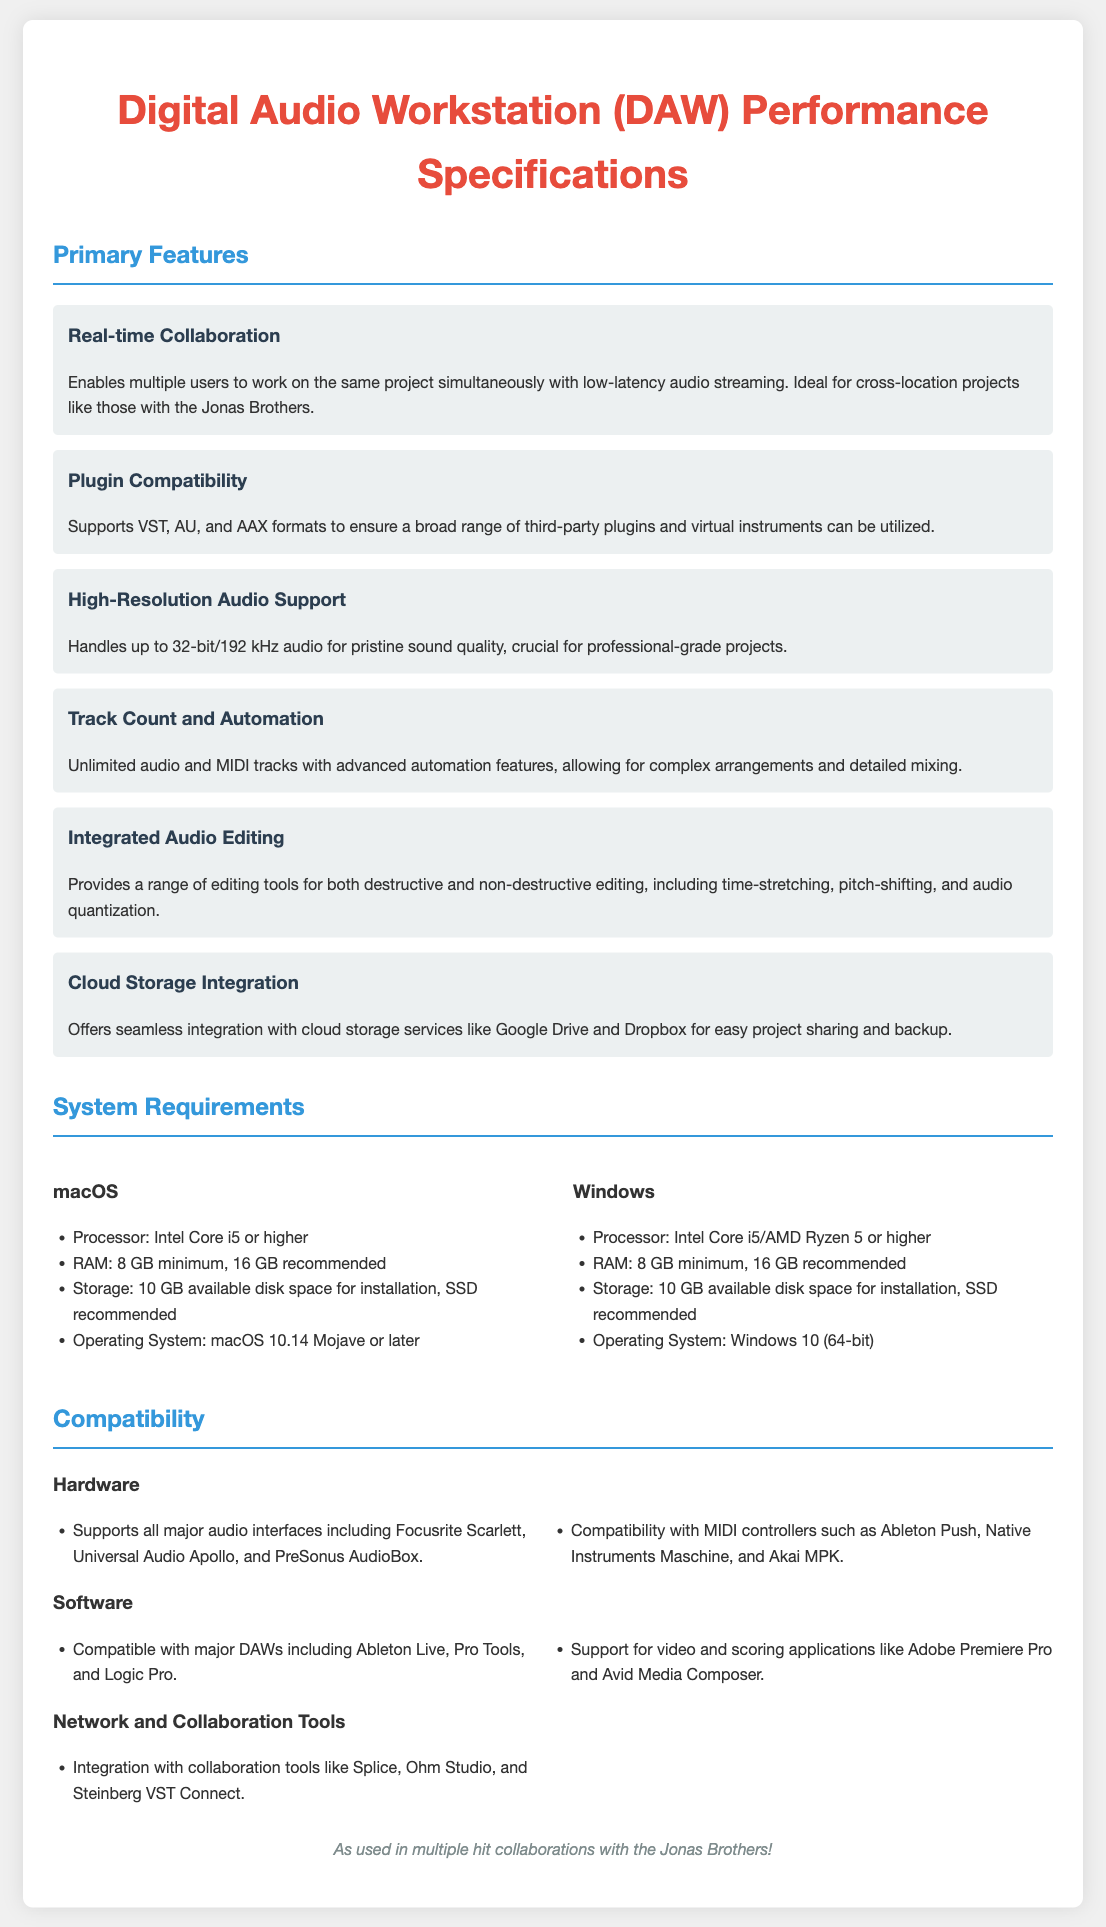what is the maximum audio resolution supported? The document specifies that the DAW handles up to 32-bit/192 kHz audio for high-quality sound.
Answer: 32-bit/192 kHz what types of audio plugins are supported? The document mentions the supported formats for audio plugins, which are VST, AU, and AAX.
Answer: VST, AU, AAX what is the minimum RAM requirement for macOS? The document states that the minimum RAM for macOS is 8 GB.
Answer: 8 GB how many tracks can the DAW handle? According to the document, the DAW can handle unlimited audio and MIDI tracks, allowing for flexible project arrangements.
Answer: Unlimited which collaboration tool is mentioned for integration? The document lists collaboration tools, specifically naming Splice as one of the integrations available.
Answer: Splice what is the recommended RAM for Windows? The document indicates that the recommended RAM for Windows is 16 GB.
Answer: 16 GB which audio interface brands are specifically mentioned? The document names several audio interface brands, including Focusrite Scarlett and Universal Audio Apollo.
Answer: Focusrite Scarlett, Universal Audio Apollo what kind of editing tools does the DAW provide? The document details that the DAW offers tools for destructive and non-destructive editing, including time-stretching and pitch-shifting.
Answer: Time-stretching, pitch-shifting what type of storage is recommended for installation? The document mentions that an SSD is recommended for installation storage.
Answer: SSD 